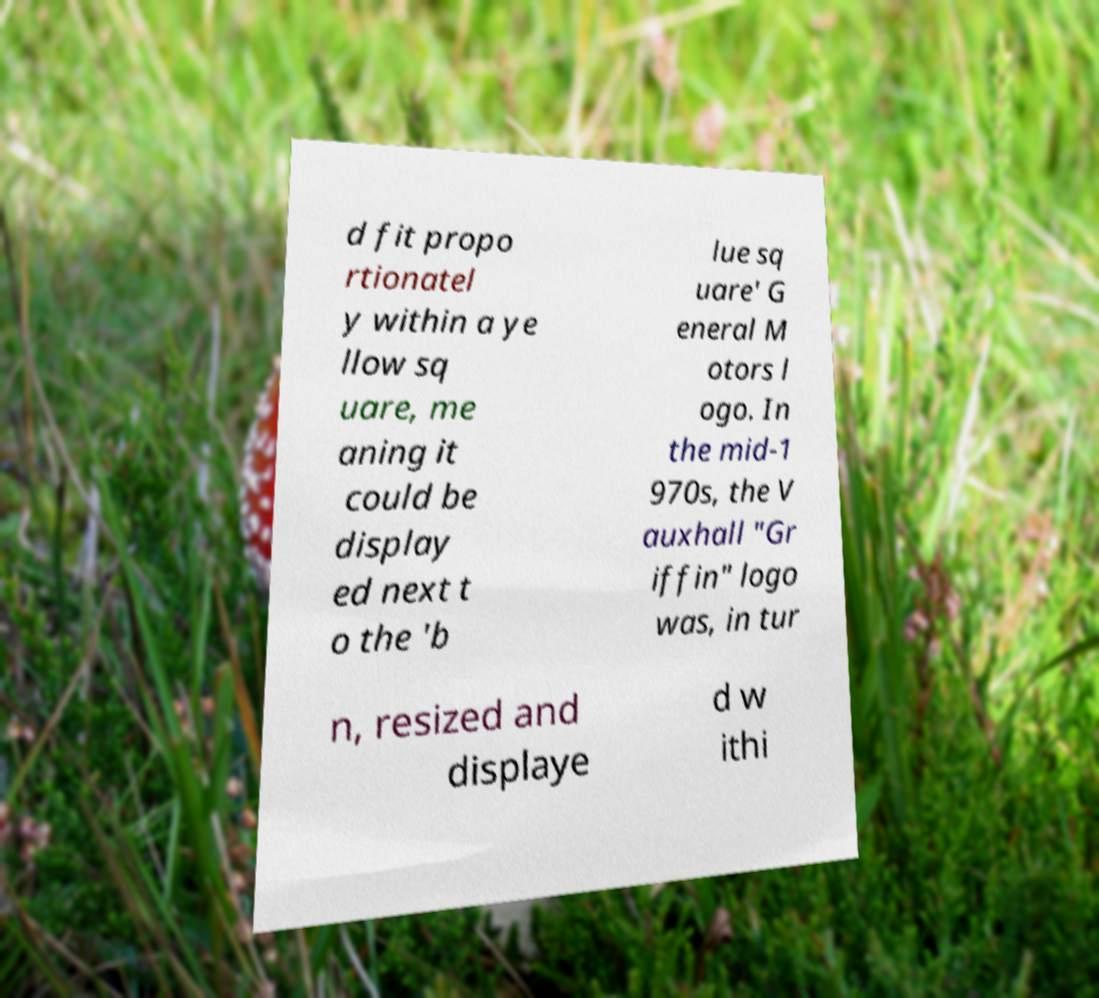Can you read and provide the text displayed in the image?This photo seems to have some interesting text. Can you extract and type it out for me? d fit propo rtionatel y within a ye llow sq uare, me aning it could be display ed next t o the 'b lue sq uare' G eneral M otors l ogo. In the mid-1 970s, the V auxhall "Gr iffin" logo was, in tur n, resized and displaye d w ithi 